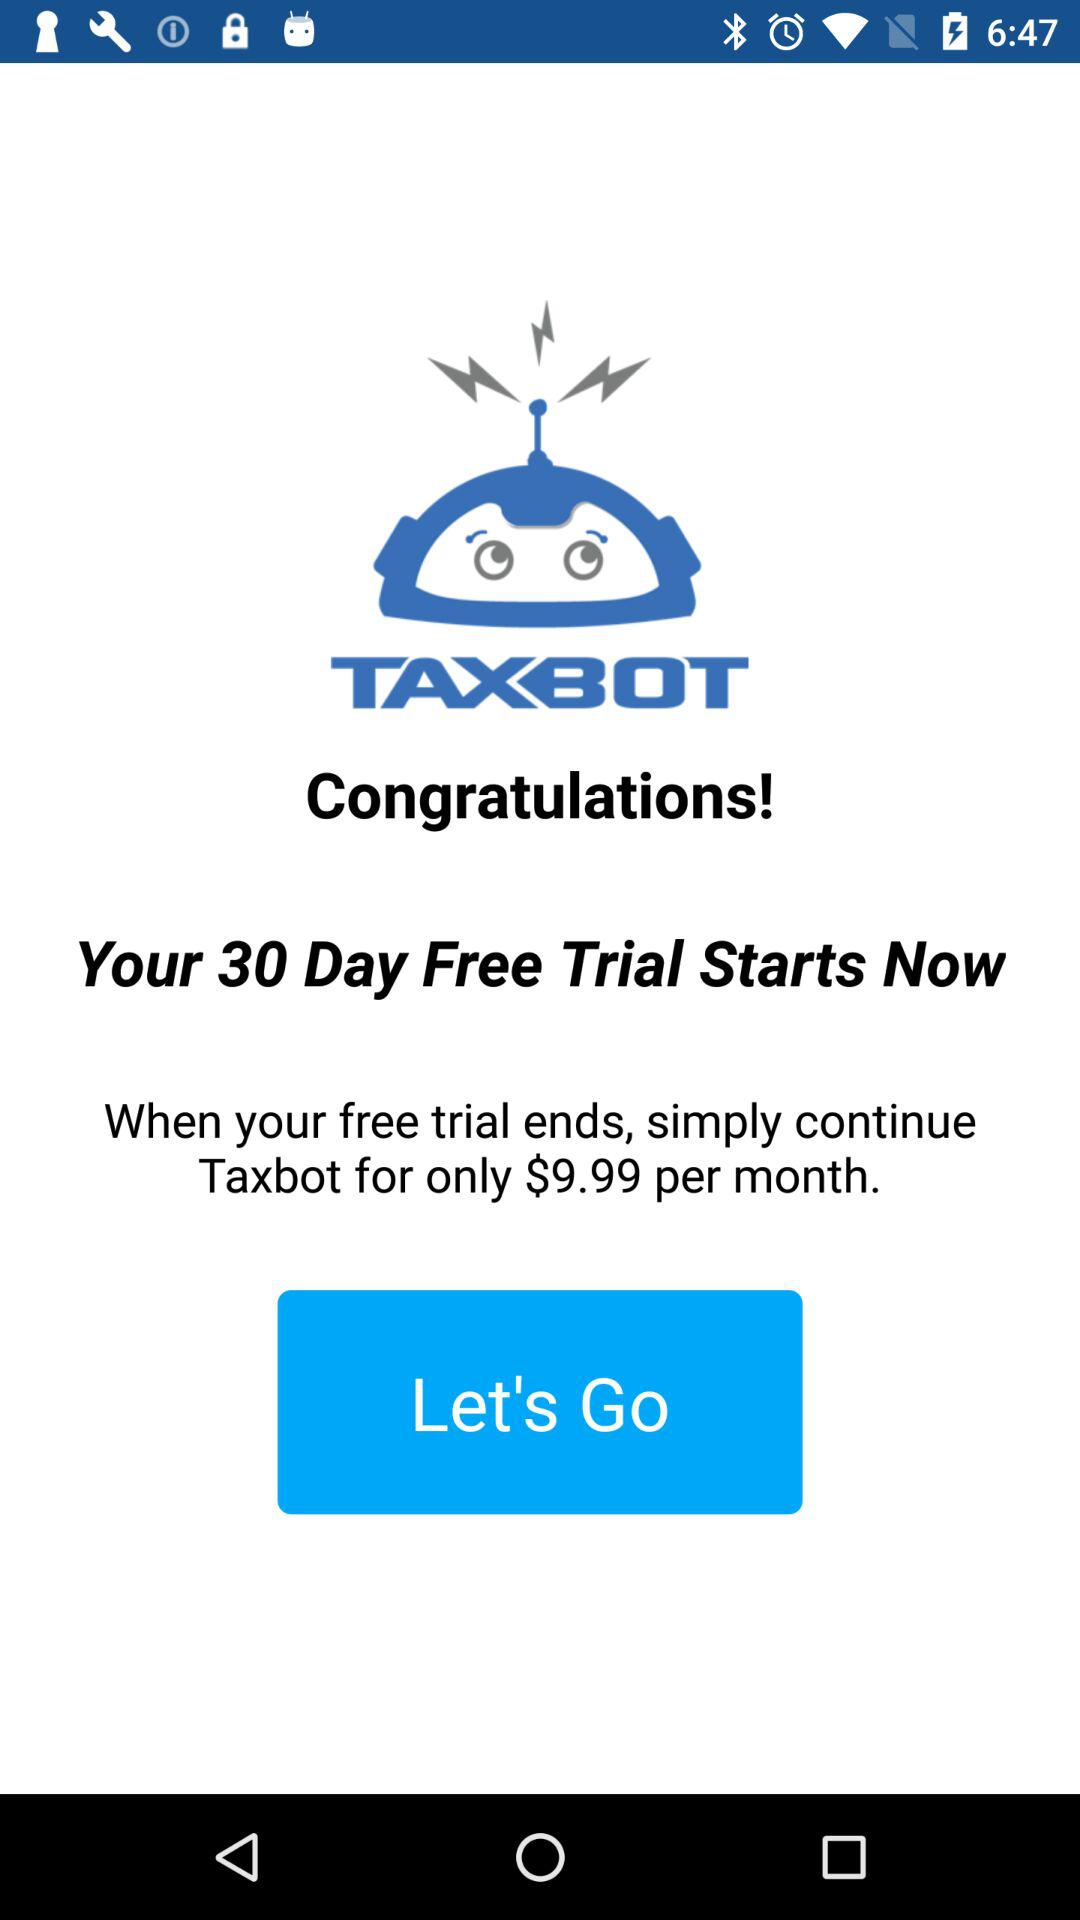What is the application name? The application name is "TAXBOT". 